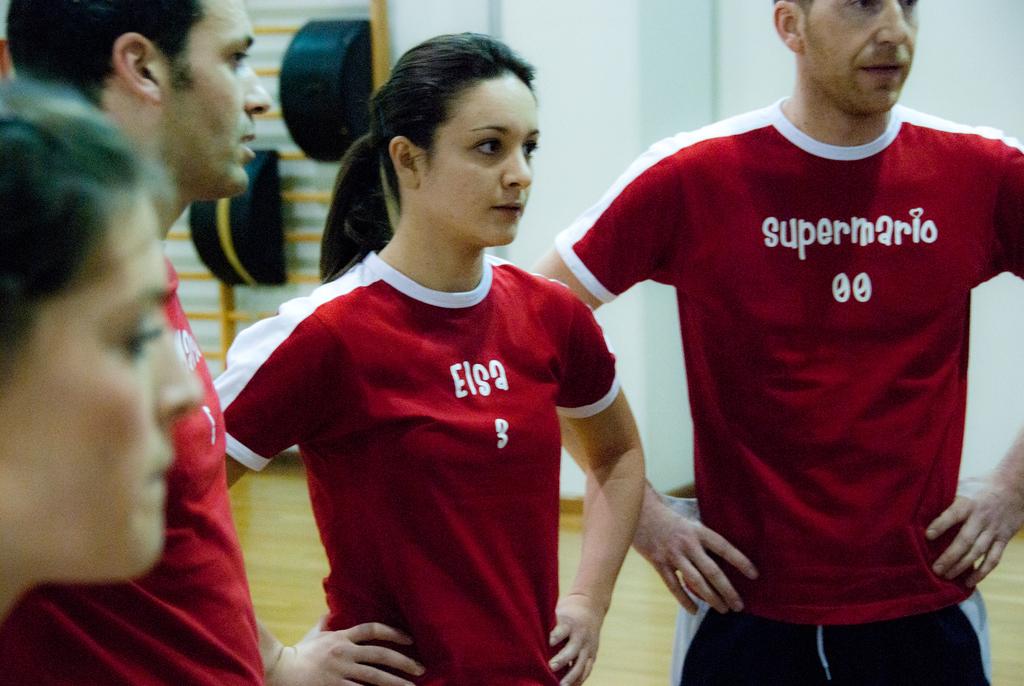What name is on the visible man's shirt?
Keep it short and to the point. Supermario. What is the number on the woman's shirt in the middle?
Your answer should be very brief. 3. 